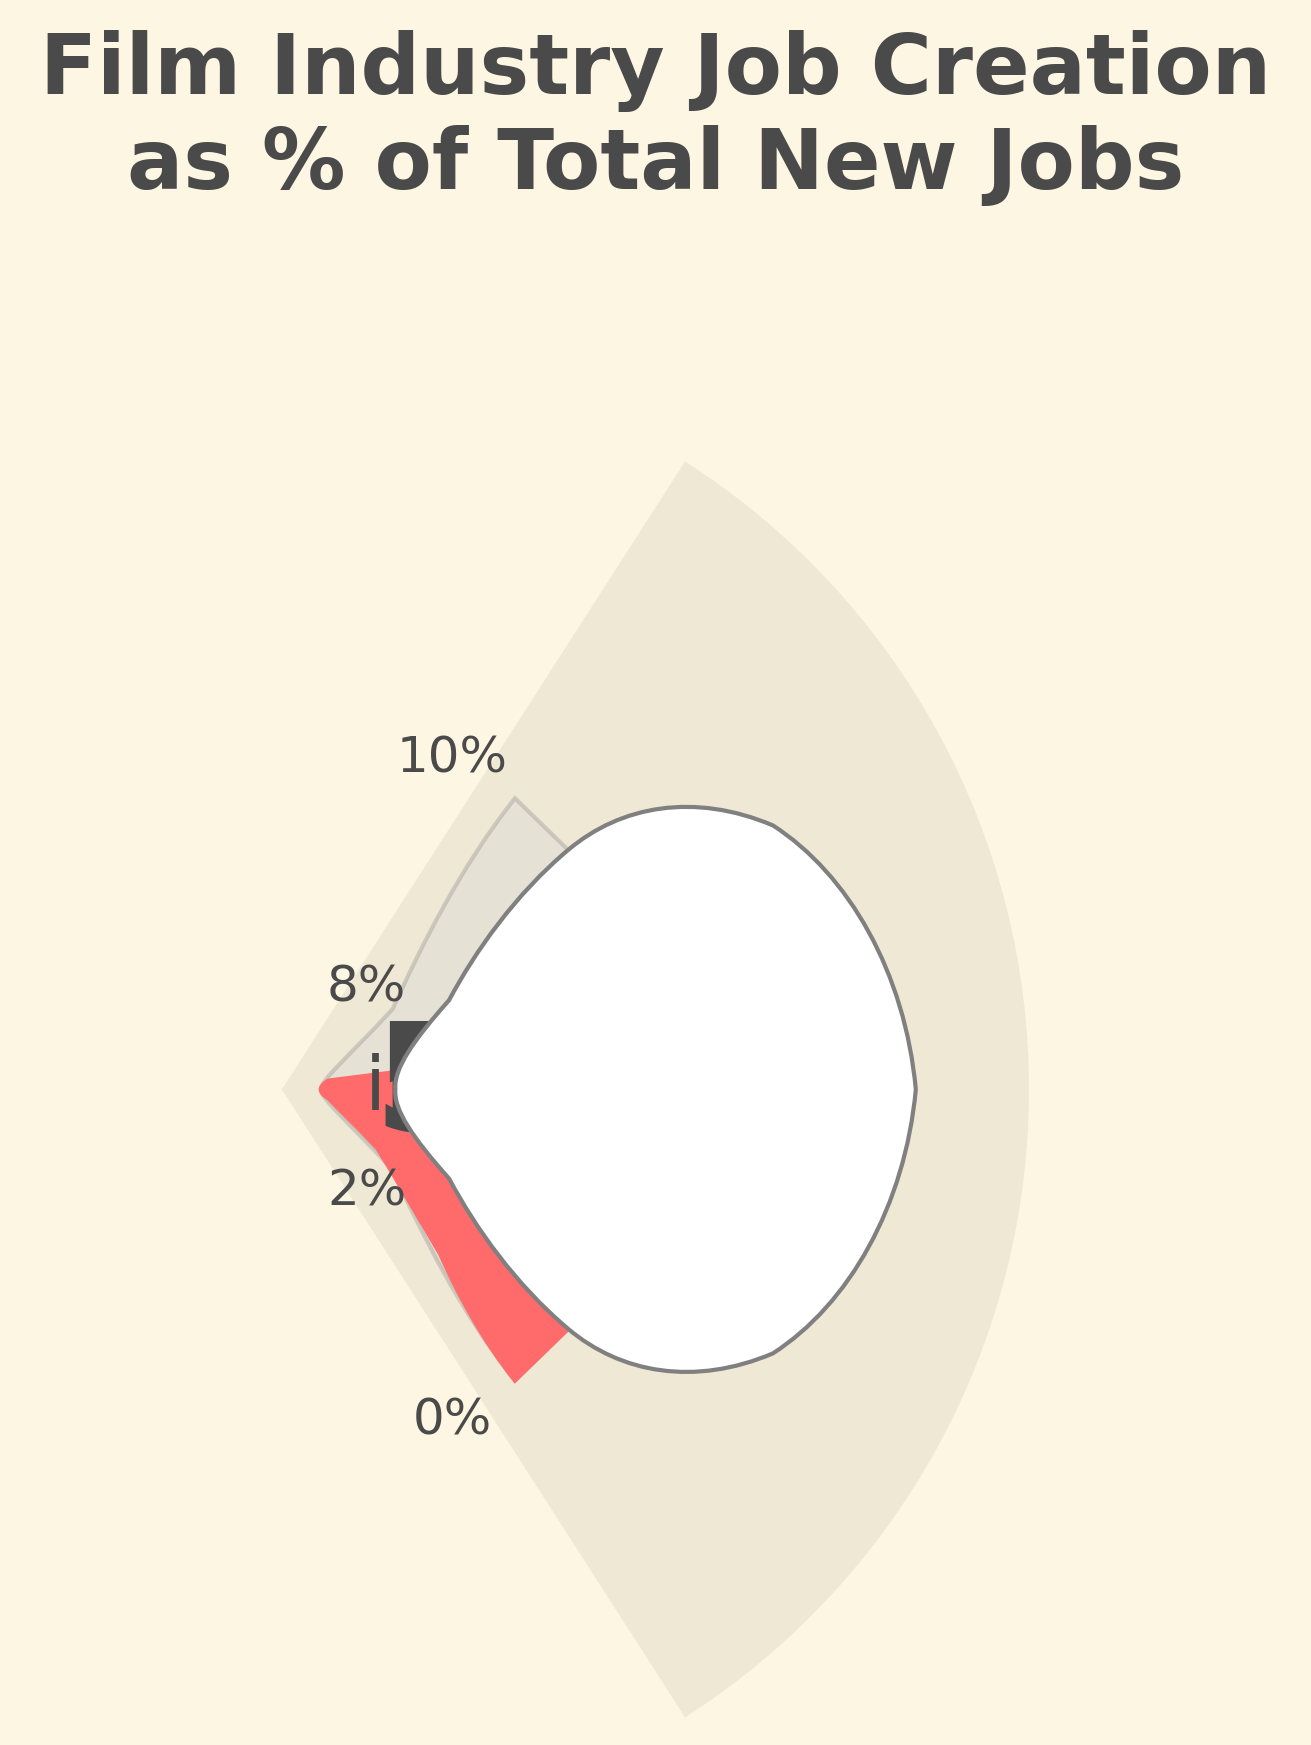what is the title of the plot? The title of the plot is usually placed at the top and provides a summary of what the plot displays. Here, it reads "Film Industry Job Creation as % of Total New Jobs".
Answer: Film Industry Job Creation as % of Total New Jobs What year does the gauge chart represent? The year is annotated just below the percentage text in the gauge chart. It indicates the most recent data point used for the visualization. The year shown is "2022".
Answer: 2022 What is the percentage of film industry job creation in 2022? The gauge chart shows a percentage value prominently within the central circle of the chart. This value indicates the film industry job creation as a percentage. The chart shows "5.7%".
Answer: 5.7% How does the percentage in 2022 compare to that in 2021? The percentages need to be extracted and compared. The gauge chart shows 5.7% for 2022. From the data, 2021 was 4.5%. Comparison shows 2022's percentage is higher.
Answer: Higher in 2022 What is the trend of film industry job creation percentage from 2018 to 2022? Observing the data provided, the percentages are 3.2% (2018), 3.8% (2019), 2.1% (2020), 4.5% (2021), and 5.7% (2022). The trend shows an overall increase over this period despite a dip in 2020.
Answer: Increasing, with a dip in 2020 What percentage labels are indicated on the gauge chart? Percentage labels typically appear around the circumference of the gauge chart. They provide reference points. The labels in the chart are 0%, 2%, 4%, 6%, 8%, and 10%.
Answer: 0%, 2%, 4%, 6%, 8%, 10% What is the difference in the percentage of film industry job creation between 2019 and 2020? First, identify the values for 2019 and 2020 from the data (3.8% and 2.1%, respectively). Then, subtract the percentage for 2020 from 2019 to find the difference. The difference is 3.8% - 2.1% = 1.7%.
Answer: 1.7% Does the gauge chart show the maximum percentage value reached in the dataset? The gauge chart illustrates the percentage for 2022 which is the latest available data. To check if it is the highest, compare with the previous years. As 5.7% is the highest in the available data, the chart shows the maximum value.
Answer: Yes 